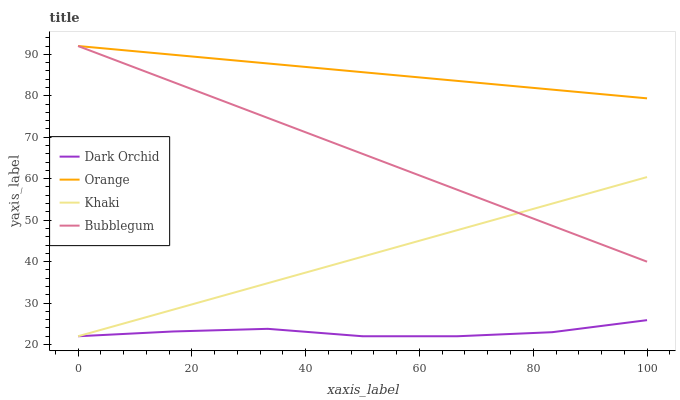Does Dark Orchid have the minimum area under the curve?
Answer yes or no. Yes. Does Orange have the maximum area under the curve?
Answer yes or no. Yes. Does Khaki have the minimum area under the curve?
Answer yes or no. No. Does Khaki have the maximum area under the curve?
Answer yes or no. No. Is Khaki the smoothest?
Answer yes or no. Yes. Is Dark Orchid the roughest?
Answer yes or no. Yes. Is Bubblegum the smoothest?
Answer yes or no. No. Is Bubblegum the roughest?
Answer yes or no. No. Does Bubblegum have the lowest value?
Answer yes or no. No. Does Bubblegum have the highest value?
Answer yes or no. Yes. Does Khaki have the highest value?
Answer yes or no. No. Is Khaki less than Orange?
Answer yes or no. Yes. Is Orange greater than Dark Orchid?
Answer yes or no. Yes. Does Bubblegum intersect Orange?
Answer yes or no. Yes. Is Bubblegum less than Orange?
Answer yes or no. No. Is Bubblegum greater than Orange?
Answer yes or no. No. Does Khaki intersect Orange?
Answer yes or no. No. 